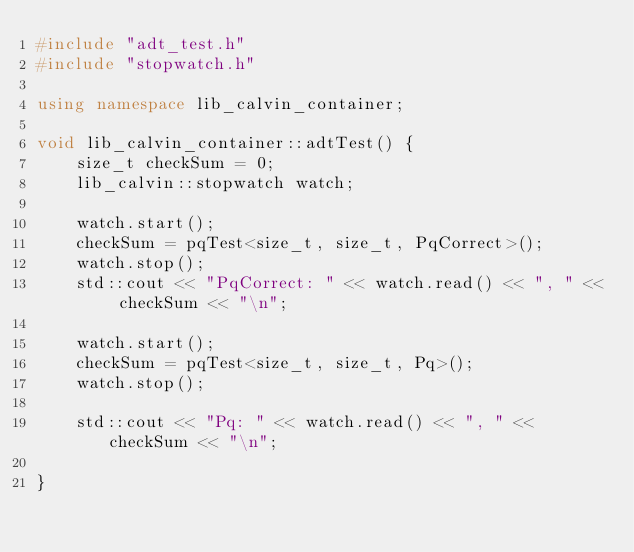<code> <loc_0><loc_0><loc_500><loc_500><_C++_>#include "adt_test.h"
#include "stopwatch.h"

using namespace lib_calvin_container;

void lib_calvin_container::adtTest() {
	size_t checkSum = 0;
	lib_calvin::stopwatch watch;

	watch.start();
	checkSum = pqTest<size_t, size_t, PqCorrect>();
	watch.stop();
	std::cout << "PqCorrect: " << watch.read() << ", " << checkSum << "\n";

	watch.start();
	checkSum = pqTest<size_t, size_t, Pq>();
	watch.stop();

	std::cout << "Pq: " << watch.read() << ", " << checkSum << "\n";

}
</code> 